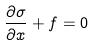Convert formula to latex. <formula><loc_0><loc_0><loc_500><loc_500>\frac { \partial \sigma } { \partial x } + f = 0</formula> 